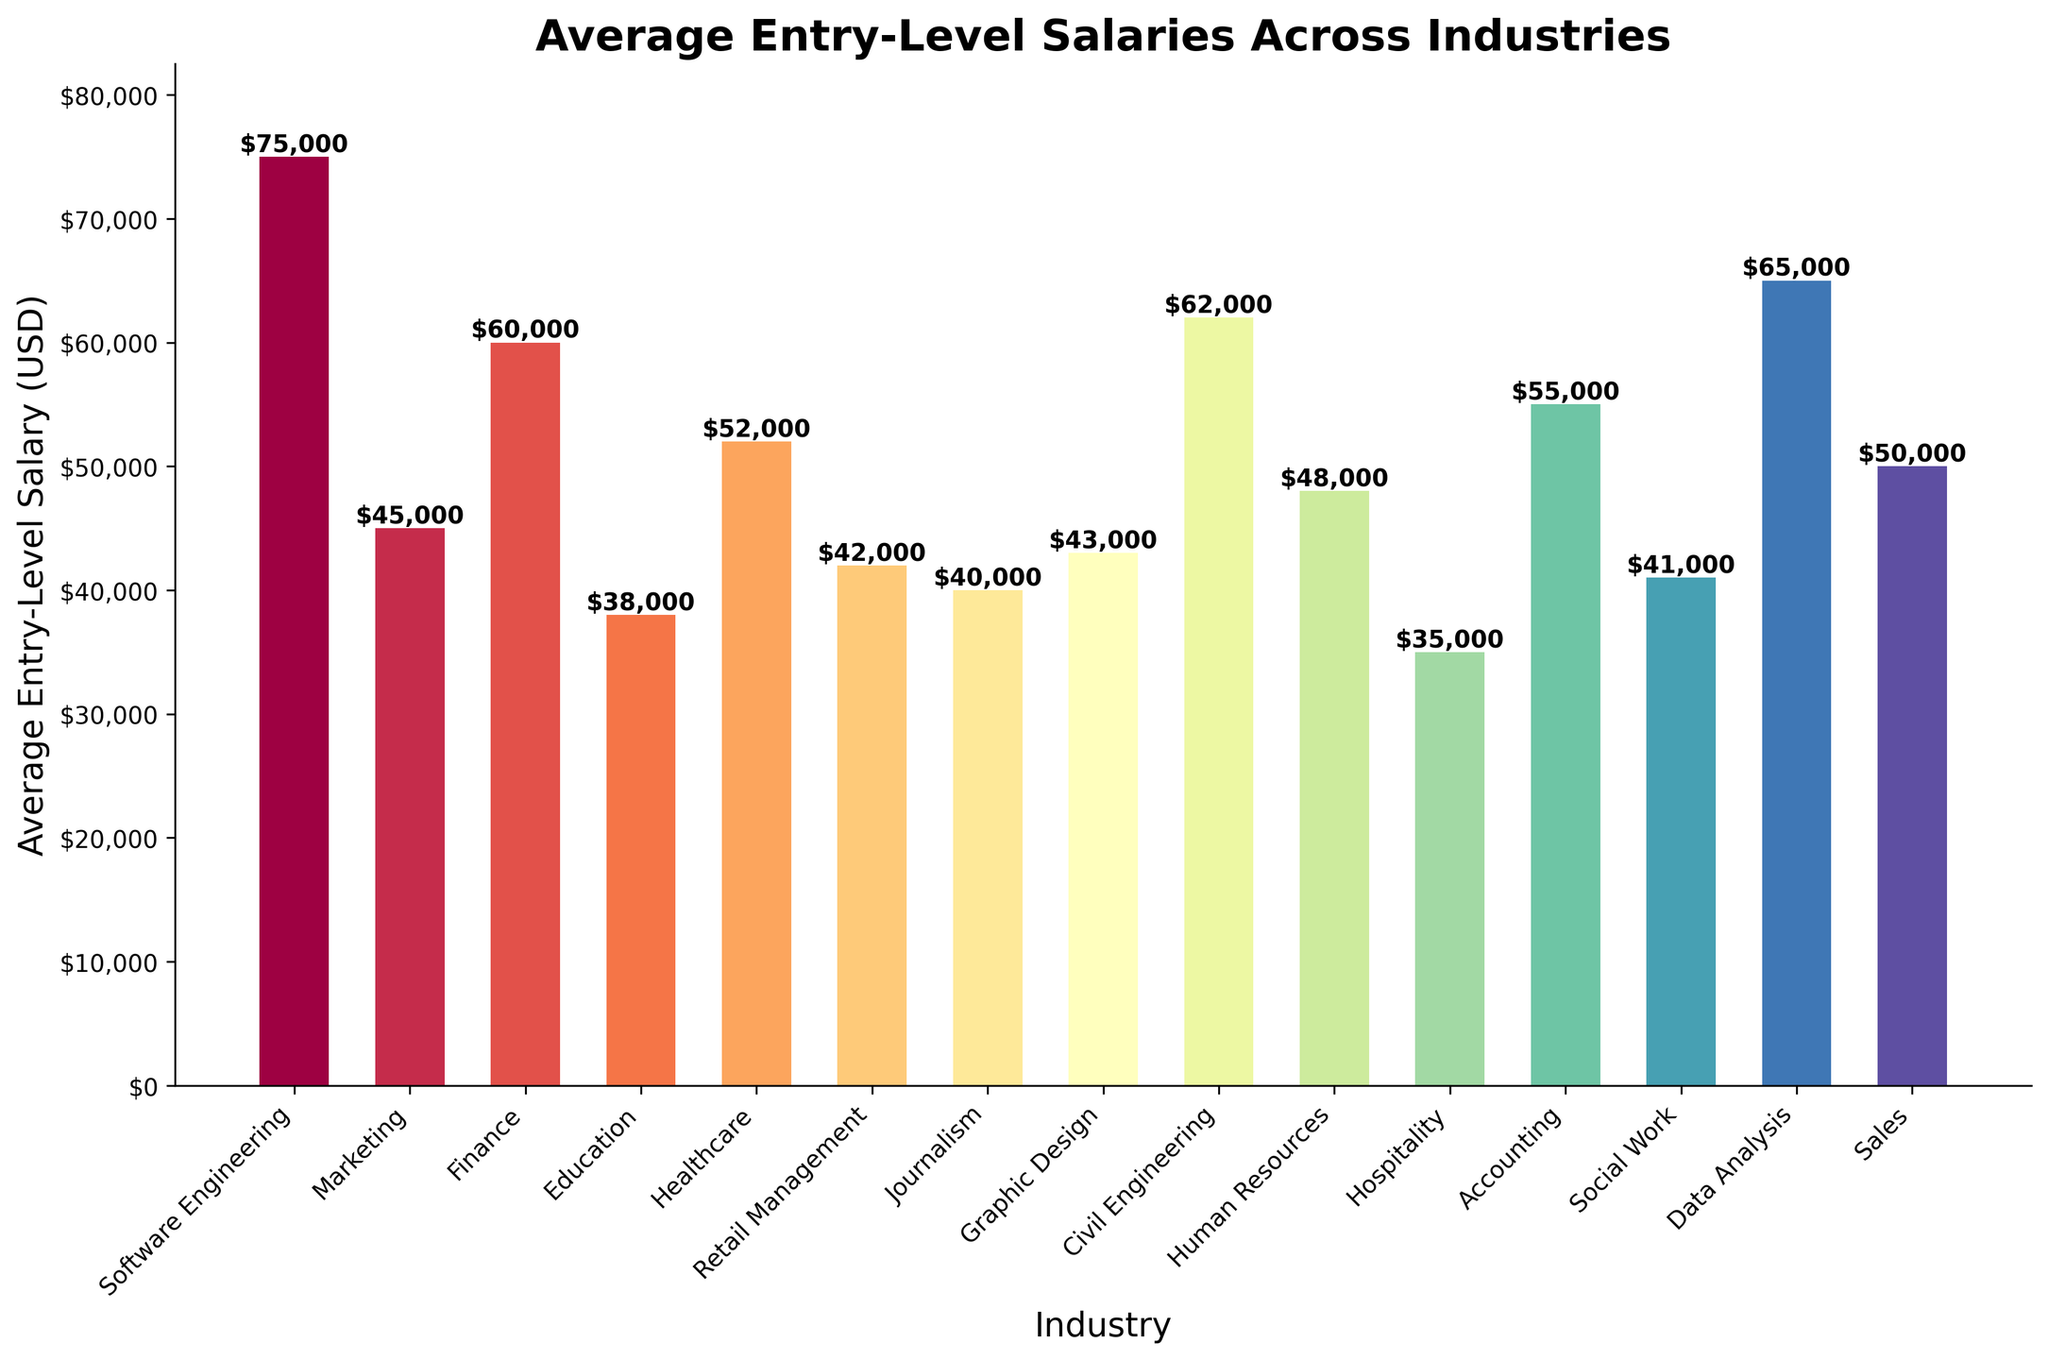Which industry has the highest average entry-level salary? The bar representing Software Engineering is the tallest among the bars, indicating it has the highest average entry-level salary.
Answer: Software Engineering Which industry has the lowest average entry-level salary? The bar representing Hospitality is the shortest, indicating it has the lowest average entry-level salary.
Answer: Hospitality How much more does a Software Engineer make compared to a Marketing professional? Compare the heights of the bars for Software Engineering and Marketing. Software Engineering is $75,000 and Marketing is $45,000. The difference is $75,000 - $45,000.
Answer: $30,000 List the industries where the average entry-level salary is above $60,000. Identify the bars that are taller than the $60,000 mark. These industries are Software Engineering, Civil Engineering, and Data Analysis.
Answer: Software Engineering, Civil Engineering, Data Analysis What is the combined average entry-level salary for Human Resources, Healthcare, and Sales? Add the average salaries for Human Resources ($48,000), Healthcare ($52,000), and Sales ($50,000). $48,000 + $52,000 + $50,000.
Answer: $150,000 By how much does the average entry-level salary in Finance exceed that in Education? Compare the heights of the bars for Finance and Education. Finance is $60,000 while Education is $38,000. The difference is $60,000 - $38,000.
Answer: $22,000 Which two industries have the closest average entry-level salaries? Compare the heights of the bars to find two bars that are nearly the same in height. Social Work ($41,000) and Journalism ($40,000) are the closest.
Answer: Social Work and Journalism What is the average entry-level salary across all listed industries? Sum the salaries $75,000 + $45,000 + $60,000 + $38,000 + $52,000 + $42,000 + $40,000 + $43,000 + $62,000 + $48,000 + $35,000 + $55,000 + $41,000 + $65,000 + $50,000 and divide by 15 (number of industries).
Answer: $50,000 Rank the top three industries by average entry-level salary. Identify the three tallest bars. Software Engineering ($75,000), Data Analysis ($65,000), and Civil Engineering ($62,000).
Answer: Software Engineering, Data Analysis, Civil Engineering Which industry experiences the smallest difference in salary compared to Healthcare? Compare Healthcare's average salary ($52,000) to each other industry to find the closest match. Retail Management is $42,000 and Human Resources is $48,000; Human Resources is the closest.
Answer: Human Resources 